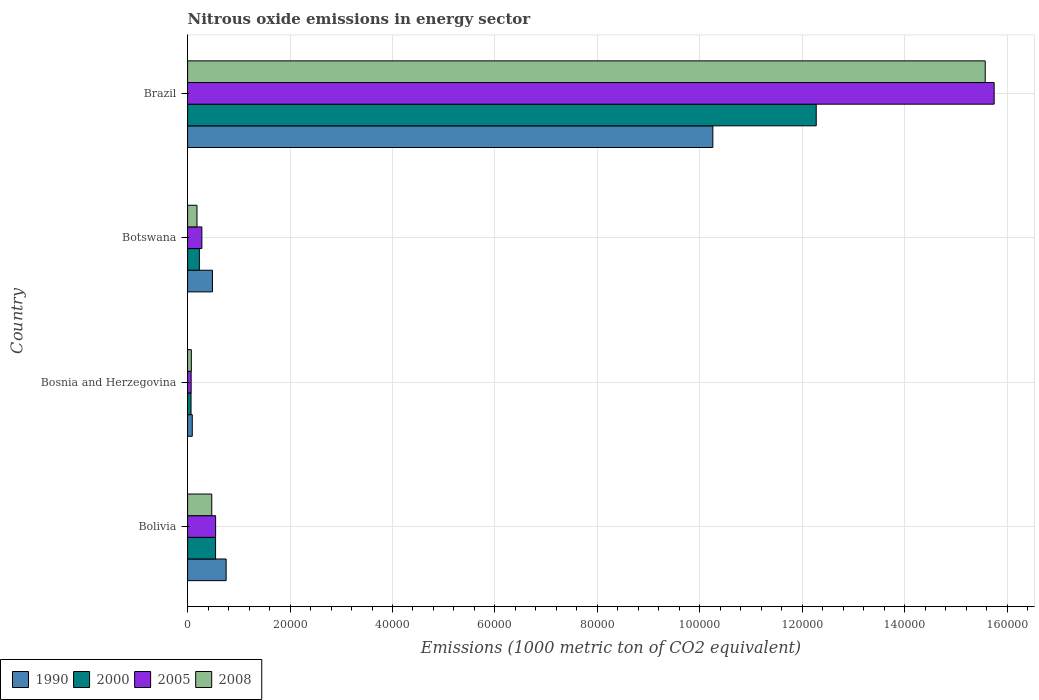How many different coloured bars are there?
Your response must be concise. 4. Are the number of bars on each tick of the Y-axis equal?
Your answer should be very brief. Yes. How many bars are there on the 1st tick from the top?
Your response must be concise. 4. What is the label of the 1st group of bars from the top?
Your answer should be very brief. Brazil. What is the amount of nitrous oxide emitted in 2008 in Bosnia and Herzegovina?
Ensure brevity in your answer.  727.1. Across all countries, what is the maximum amount of nitrous oxide emitted in 1990?
Your answer should be compact. 1.03e+05. Across all countries, what is the minimum amount of nitrous oxide emitted in 2008?
Provide a short and direct response. 727.1. In which country was the amount of nitrous oxide emitted in 2000 minimum?
Your response must be concise. Bosnia and Herzegovina. What is the total amount of nitrous oxide emitted in 1990 in the graph?
Offer a terse response. 1.16e+05. What is the difference between the amount of nitrous oxide emitted in 2008 in Bosnia and Herzegovina and that in Botswana?
Offer a terse response. -1108.7. What is the difference between the amount of nitrous oxide emitted in 2008 in Bolivia and the amount of nitrous oxide emitted in 2005 in Brazil?
Your answer should be compact. -1.53e+05. What is the average amount of nitrous oxide emitted in 1990 per country?
Provide a short and direct response. 2.90e+04. What is the difference between the amount of nitrous oxide emitted in 1990 and amount of nitrous oxide emitted in 2000 in Bosnia and Herzegovina?
Your answer should be compact. 242.9. In how many countries, is the amount of nitrous oxide emitted in 2000 greater than 64000 1000 metric ton?
Make the answer very short. 1. What is the ratio of the amount of nitrous oxide emitted in 2008 in Botswana to that in Brazil?
Ensure brevity in your answer.  0.01. Is the difference between the amount of nitrous oxide emitted in 1990 in Bosnia and Herzegovina and Brazil greater than the difference between the amount of nitrous oxide emitted in 2000 in Bosnia and Herzegovina and Brazil?
Give a very brief answer. Yes. What is the difference between the highest and the second highest amount of nitrous oxide emitted in 2008?
Ensure brevity in your answer.  1.51e+05. What is the difference between the highest and the lowest amount of nitrous oxide emitted in 1990?
Make the answer very short. 1.02e+05. What does the 1st bar from the top in Bosnia and Herzegovina represents?
Your response must be concise. 2008. What does the 2nd bar from the bottom in Botswana represents?
Offer a terse response. 2000. Are all the bars in the graph horizontal?
Offer a terse response. Yes. How many countries are there in the graph?
Keep it short and to the point. 4. What is the difference between two consecutive major ticks on the X-axis?
Offer a very short reply. 2.00e+04. Are the values on the major ticks of X-axis written in scientific E-notation?
Keep it short and to the point. No. What is the title of the graph?
Make the answer very short. Nitrous oxide emissions in energy sector. Does "1966" appear as one of the legend labels in the graph?
Your answer should be compact. No. What is the label or title of the X-axis?
Provide a short and direct response. Emissions (1000 metric ton of CO2 equivalent). What is the label or title of the Y-axis?
Your answer should be very brief. Country. What is the Emissions (1000 metric ton of CO2 equivalent) of 1990 in Bolivia?
Your answer should be compact. 7525.2. What is the Emissions (1000 metric ton of CO2 equivalent) in 2000 in Bolivia?
Make the answer very short. 5463.1. What is the Emissions (1000 metric ton of CO2 equivalent) in 2005 in Bolivia?
Your answer should be very brief. 5470.8. What is the Emissions (1000 metric ton of CO2 equivalent) in 2008 in Bolivia?
Keep it short and to the point. 4717.4. What is the Emissions (1000 metric ton of CO2 equivalent) in 1990 in Bosnia and Herzegovina?
Offer a very short reply. 912.2. What is the Emissions (1000 metric ton of CO2 equivalent) of 2000 in Bosnia and Herzegovina?
Give a very brief answer. 669.3. What is the Emissions (1000 metric ton of CO2 equivalent) of 2005 in Bosnia and Herzegovina?
Give a very brief answer. 691.3. What is the Emissions (1000 metric ton of CO2 equivalent) in 2008 in Bosnia and Herzegovina?
Provide a succinct answer. 727.1. What is the Emissions (1000 metric ton of CO2 equivalent) of 1990 in Botswana?
Keep it short and to the point. 4852.7. What is the Emissions (1000 metric ton of CO2 equivalent) of 2000 in Botswana?
Make the answer very short. 2299. What is the Emissions (1000 metric ton of CO2 equivalent) in 2005 in Botswana?
Provide a short and direct response. 2784.6. What is the Emissions (1000 metric ton of CO2 equivalent) in 2008 in Botswana?
Give a very brief answer. 1835.8. What is the Emissions (1000 metric ton of CO2 equivalent) of 1990 in Brazil?
Offer a terse response. 1.03e+05. What is the Emissions (1000 metric ton of CO2 equivalent) of 2000 in Brazil?
Make the answer very short. 1.23e+05. What is the Emissions (1000 metric ton of CO2 equivalent) of 2005 in Brazil?
Ensure brevity in your answer.  1.57e+05. What is the Emissions (1000 metric ton of CO2 equivalent) in 2008 in Brazil?
Your answer should be compact. 1.56e+05. Across all countries, what is the maximum Emissions (1000 metric ton of CO2 equivalent) of 1990?
Ensure brevity in your answer.  1.03e+05. Across all countries, what is the maximum Emissions (1000 metric ton of CO2 equivalent) in 2000?
Your answer should be compact. 1.23e+05. Across all countries, what is the maximum Emissions (1000 metric ton of CO2 equivalent) of 2005?
Ensure brevity in your answer.  1.57e+05. Across all countries, what is the maximum Emissions (1000 metric ton of CO2 equivalent) of 2008?
Your answer should be compact. 1.56e+05. Across all countries, what is the minimum Emissions (1000 metric ton of CO2 equivalent) of 1990?
Your answer should be very brief. 912.2. Across all countries, what is the minimum Emissions (1000 metric ton of CO2 equivalent) of 2000?
Offer a very short reply. 669.3. Across all countries, what is the minimum Emissions (1000 metric ton of CO2 equivalent) in 2005?
Your answer should be compact. 691.3. Across all countries, what is the minimum Emissions (1000 metric ton of CO2 equivalent) of 2008?
Ensure brevity in your answer.  727.1. What is the total Emissions (1000 metric ton of CO2 equivalent) in 1990 in the graph?
Make the answer very short. 1.16e+05. What is the total Emissions (1000 metric ton of CO2 equivalent) of 2000 in the graph?
Provide a short and direct response. 1.31e+05. What is the total Emissions (1000 metric ton of CO2 equivalent) in 2005 in the graph?
Make the answer very short. 1.66e+05. What is the total Emissions (1000 metric ton of CO2 equivalent) in 2008 in the graph?
Ensure brevity in your answer.  1.63e+05. What is the difference between the Emissions (1000 metric ton of CO2 equivalent) in 1990 in Bolivia and that in Bosnia and Herzegovina?
Your answer should be very brief. 6613. What is the difference between the Emissions (1000 metric ton of CO2 equivalent) in 2000 in Bolivia and that in Bosnia and Herzegovina?
Provide a short and direct response. 4793.8. What is the difference between the Emissions (1000 metric ton of CO2 equivalent) of 2005 in Bolivia and that in Bosnia and Herzegovina?
Your response must be concise. 4779.5. What is the difference between the Emissions (1000 metric ton of CO2 equivalent) of 2008 in Bolivia and that in Bosnia and Herzegovina?
Your answer should be compact. 3990.3. What is the difference between the Emissions (1000 metric ton of CO2 equivalent) of 1990 in Bolivia and that in Botswana?
Offer a very short reply. 2672.5. What is the difference between the Emissions (1000 metric ton of CO2 equivalent) of 2000 in Bolivia and that in Botswana?
Offer a terse response. 3164.1. What is the difference between the Emissions (1000 metric ton of CO2 equivalent) in 2005 in Bolivia and that in Botswana?
Offer a terse response. 2686.2. What is the difference between the Emissions (1000 metric ton of CO2 equivalent) in 2008 in Bolivia and that in Botswana?
Ensure brevity in your answer.  2881.6. What is the difference between the Emissions (1000 metric ton of CO2 equivalent) in 1990 in Bolivia and that in Brazil?
Your response must be concise. -9.50e+04. What is the difference between the Emissions (1000 metric ton of CO2 equivalent) of 2000 in Bolivia and that in Brazil?
Your answer should be very brief. -1.17e+05. What is the difference between the Emissions (1000 metric ton of CO2 equivalent) in 2005 in Bolivia and that in Brazil?
Ensure brevity in your answer.  -1.52e+05. What is the difference between the Emissions (1000 metric ton of CO2 equivalent) in 2008 in Bolivia and that in Brazil?
Make the answer very short. -1.51e+05. What is the difference between the Emissions (1000 metric ton of CO2 equivalent) in 1990 in Bosnia and Herzegovina and that in Botswana?
Offer a terse response. -3940.5. What is the difference between the Emissions (1000 metric ton of CO2 equivalent) of 2000 in Bosnia and Herzegovina and that in Botswana?
Your answer should be compact. -1629.7. What is the difference between the Emissions (1000 metric ton of CO2 equivalent) in 2005 in Bosnia and Herzegovina and that in Botswana?
Your answer should be compact. -2093.3. What is the difference between the Emissions (1000 metric ton of CO2 equivalent) of 2008 in Bosnia and Herzegovina and that in Botswana?
Provide a succinct answer. -1108.7. What is the difference between the Emissions (1000 metric ton of CO2 equivalent) of 1990 in Bosnia and Herzegovina and that in Brazil?
Your answer should be compact. -1.02e+05. What is the difference between the Emissions (1000 metric ton of CO2 equivalent) in 2000 in Bosnia and Herzegovina and that in Brazil?
Make the answer very short. -1.22e+05. What is the difference between the Emissions (1000 metric ton of CO2 equivalent) of 2005 in Bosnia and Herzegovina and that in Brazil?
Your answer should be compact. -1.57e+05. What is the difference between the Emissions (1000 metric ton of CO2 equivalent) of 2008 in Bosnia and Herzegovina and that in Brazil?
Ensure brevity in your answer.  -1.55e+05. What is the difference between the Emissions (1000 metric ton of CO2 equivalent) in 1990 in Botswana and that in Brazil?
Make the answer very short. -9.77e+04. What is the difference between the Emissions (1000 metric ton of CO2 equivalent) of 2000 in Botswana and that in Brazil?
Provide a short and direct response. -1.20e+05. What is the difference between the Emissions (1000 metric ton of CO2 equivalent) in 2005 in Botswana and that in Brazil?
Your answer should be very brief. -1.55e+05. What is the difference between the Emissions (1000 metric ton of CO2 equivalent) of 2008 in Botswana and that in Brazil?
Make the answer very short. -1.54e+05. What is the difference between the Emissions (1000 metric ton of CO2 equivalent) in 1990 in Bolivia and the Emissions (1000 metric ton of CO2 equivalent) in 2000 in Bosnia and Herzegovina?
Give a very brief answer. 6855.9. What is the difference between the Emissions (1000 metric ton of CO2 equivalent) of 1990 in Bolivia and the Emissions (1000 metric ton of CO2 equivalent) of 2005 in Bosnia and Herzegovina?
Make the answer very short. 6833.9. What is the difference between the Emissions (1000 metric ton of CO2 equivalent) of 1990 in Bolivia and the Emissions (1000 metric ton of CO2 equivalent) of 2008 in Bosnia and Herzegovina?
Offer a very short reply. 6798.1. What is the difference between the Emissions (1000 metric ton of CO2 equivalent) of 2000 in Bolivia and the Emissions (1000 metric ton of CO2 equivalent) of 2005 in Bosnia and Herzegovina?
Provide a short and direct response. 4771.8. What is the difference between the Emissions (1000 metric ton of CO2 equivalent) in 2000 in Bolivia and the Emissions (1000 metric ton of CO2 equivalent) in 2008 in Bosnia and Herzegovina?
Ensure brevity in your answer.  4736. What is the difference between the Emissions (1000 metric ton of CO2 equivalent) in 2005 in Bolivia and the Emissions (1000 metric ton of CO2 equivalent) in 2008 in Bosnia and Herzegovina?
Make the answer very short. 4743.7. What is the difference between the Emissions (1000 metric ton of CO2 equivalent) in 1990 in Bolivia and the Emissions (1000 metric ton of CO2 equivalent) in 2000 in Botswana?
Provide a succinct answer. 5226.2. What is the difference between the Emissions (1000 metric ton of CO2 equivalent) in 1990 in Bolivia and the Emissions (1000 metric ton of CO2 equivalent) in 2005 in Botswana?
Provide a succinct answer. 4740.6. What is the difference between the Emissions (1000 metric ton of CO2 equivalent) of 1990 in Bolivia and the Emissions (1000 metric ton of CO2 equivalent) of 2008 in Botswana?
Ensure brevity in your answer.  5689.4. What is the difference between the Emissions (1000 metric ton of CO2 equivalent) of 2000 in Bolivia and the Emissions (1000 metric ton of CO2 equivalent) of 2005 in Botswana?
Your answer should be very brief. 2678.5. What is the difference between the Emissions (1000 metric ton of CO2 equivalent) of 2000 in Bolivia and the Emissions (1000 metric ton of CO2 equivalent) of 2008 in Botswana?
Offer a terse response. 3627.3. What is the difference between the Emissions (1000 metric ton of CO2 equivalent) in 2005 in Bolivia and the Emissions (1000 metric ton of CO2 equivalent) in 2008 in Botswana?
Your response must be concise. 3635. What is the difference between the Emissions (1000 metric ton of CO2 equivalent) of 1990 in Bolivia and the Emissions (1000 metric ton of CO2 equivalent) of 2000 in Brazil?
Give a very brief answer. -1.15e+05. What is the difference between the Emissions (1000 metric ton of CO2 equivalent) in 1990 in Bolivia and the Emissions (1000 metric ton of CO2 equivalent) in 2005 in Brazil?
Keep it short and to the point. -1.50e+05. What is the difference between the Emissions (1000 metric ton of CO2 equivalent) in 1990 in Bolivia and the Emissions (1000 metric ton of CO2 equivalent) in 2008 in Brazil?
Provide a succinct answer. -1.48e+05. What is the difference between the Emissions (1000 metric ton of CO2 equivalent) in 2000 in Bolivia and the Emissions (1000 metric ton of CO2 equivalent) in 2005 in Brazil?
Keep it short and to the point. -1.52e+05. What is the difference between the Emissions (1000 metric ton of CO2 equivalent) of 2000 in Bolivia and the Emissions (1000 metric ton of CO2 equivalent) of 2008 in Brazil?
Offer a terse response. -1.50e+05. What is the difference between the Emissions (1000 metric ton of CO2 equivalent) in 2005 in Bolivia and the Emissions (1000 metric ton of CO2 equivalent) in 2008 in Brazil?
Offer a terse response. -1.50e+05. What is the difference between the Emissions (1000 metric ton of CO2 equivalent) in 1990 in Bosnia and Herzegovina and the Emissions (1000 metric ton of CO2 equivalent) in 2000 in Botswana?
Provide a succinct answer. -1386.8. What is the difference between the Emissions (1000 metric ton of CO2 equivalent) of 1990 in Bosnia and Herzegovina and the Emissions (1000 metric ton of CO2 equivalent) of 2005 in Botswana?
Provide a short and direct response. -1872.4. What is the difference between the Emissions (1000 metric ton of CO2 equivalent) in 1990 in Bosnia and Herzegovina and the Emissions (1000 metric ton of CO2 equivalent) in 2008 in Botswana?
Offer a very short reply. -923.6. What is the difference between the Emissions (1000 metric ton of CO2 equivalent) of 2000 in Bosnia and Herzegovina and the Emissions (1000 metric ton of CO2 equivalent) of 2005 in Botswana?
Offer a very short reply. -2115.3. What is the difference between the Emissions (1000 metric ton of CO2 equivalent) of 2000 in Bosnia and Herzegovina and the Emissions (1000 metric ton of CO2 equivalent) of 2008 in Botswana?
Offer a very short reply. -1166.5. What is the difference between the Emissions (1000 metric ton of CO2 equivalent) in 2005 in Bosnia and Herzegovina and the Emissions (1000 metric ton of CO2 equivalent) in 2008 in Botswana?
Give a very brief answer. -1144.5. What is the difference between the Emissions (1000 metric ton of CO2 equivalent) of 1990 in Bosnia and Herzegovina and the Emissions (1000 metric ton of CO2 equivalent) of 2000 in Brazil?
Give a very brief answer. -1.22e+05. What is the difference between the Emissions (1000 metric ton of CO2 equivalent) in 1990 in Bosnia and Herzegovina and the Emissions (1000 metric ton of CO2 equivalent) in 2005 in Brazil?
Make the answer very short. -1.57e+05. What is the difference between the Emissions (1000 metric ton of CO2 equivalent) in 1990 in Bosnia and Herzegovina and the Emissions (1000 metric ton of CO2 equivalent) in 2008 in Brazil?
Keep it short and to the point. -1.55e+05. What is the difference between the Emissions (1000 metric ton of CO2 equivalent) in 2000 in Bosnia and Herzegovina and the Emissions (1000 metric ton of CO2 equivalent) in 2005 in Brazil?
Offer a terse response. -1.57e+05. What is the difference between the Emissions (1000 metric ton of CO2 equivalent) in 2000 in Bosnia and Herzegovina and the Emissions (1000 metric ton of CO2 equivalent) in 2008 in Brazil?
Your answer should be very brief. -1.55e+05. What is the difference between the Emissions (1000 metric ton of CO2 equivalent) in 2005 in Bosnia and Herzegovina and the Emissions (1000 metric ton of CO2 equivalent) in 2008 in Brazil?
Ensure brevity in your answer.  -1.55e+05. What is the difference between the Emissions (1000 metric ton of CO2 equivalent) in 1990 in Botswana and the Emissions (1000 metric ton of CO2 equivalent) in 2000 in Brazil?
Your answer should be compact. -1.18e+05. What is the difference between the Emissions (1000 metric ton of CO2 equivalent) of 1990 in Botswana and the Emissions (1000 metric ton of CO2 equivalent) of 2005 in Brazil?
Provide a short and direct response. -1.53e+05. What is the difference between the Emissions (1000 metric ton of CO2 equivalent) in 1990 in Botswana and the Emissions (1000 metric ton of CO2 equivalent) in 2008 in Brazil?
Offer a terse response. -1.51e+05. What is the difference between the Emissions (1000 metric ton of CO2 equivalent) in 2000 in Botswana and the Emissions (1000 metric ton of CO2 equivalent) in 2005 in Brazil?
Your response must be concise. -1.55e+05. What is the difference between the Emissions (1000 metric ton of CO2 equivalent) in 2000 in Botswana and the Emissions (1000 metric ton of CO2 equivalent) in 2008 in Brazil?
Keep it short and to the point. -1.53e+05. What is the difference between the Emissions (1000 metric ton of CO2 equivalent) of 2005 in Botswana and the Emissions (1000 metric ton of CO2 equivalent) of 2008 in Brazil?
Keep it short and to the point. -1.53e+05. What is the average Emissions (1000 metric ton of CO2 equivalent) in 1990 per country?
Ensure brevity in your answer.  2.90e+04. What is the average Emissions (1000 metric ton of CO2 equivalent) of 2000 per country?
Your response must be concise. 3.28e+04. What is the average Emissions (1000 metric ton of CO2 equivalent) in 2005 per country?
Ensure brevity in your answer.  4.16e+04. What is the average Emissions (1000 metric ton of CO2 equivalent) of 2008 per country?
Your answer should be very brief. 4.07e+04. What is the difference between the Emissions (1000 metric ton of CO2 equivalent) of 1990 and Emissions (1000 metric ton of CO2 equivalent) of 2000 in Bolivia?
Offer a very short reply. 2062.1. What is the difference between the Emissions (1000 metric ton of CO2 equivalent) of 1990 and Emissions (1000 metric ton of CO2 equivalent) of 2005 in Bolivia?
Provide a succinct answer. 2054.4. What is the difference between the Emissions (1000 metric ton of CO2 equivalent) of 1990 and Emissions (1000 metric ton of CO2 equivalent) of 2008 in Bolivia?
Keep it short and to the point. 2807.8. What is the difference between the Emissions (1000 metric ton of CO2 equivalent) in 2000 and Emissions (1000 metric ton of CO2 equivalent) in 2005 in Bolivia?
Give a very brief answer. -7.7. What is the difference between the Emissions (1000 metric ton of CO2 equivalent) of 2000 and Emissions (1000 metric ton of CO2 equivalent) of 2008 in Bolivia?
Your answer should be compact. 745.7. What is the difference between the Emissions (1000 metric ton of CO2 equivalent) in 2005 and Emissions (1000 metric ton of CO2 equivalent) in 2008 in Bolivia?
Your answer should be very brief. 753.4. What is the difference between the Emissions (1000 metric ton of CO2 equivalent) of 1990 and Emissions (1000 metric ton of CO2 equivalent) of 2000 in Bosnia and Herzegovina?
Offer a very short reply. 242.9. What is the difference between the Emissions (1000 metric ton of CO2 equivalent) in 1990 and Emissions (1000 metric ton of CO2 equivalent) in 2005 in Bosnia and Herzegovina?
Offer a terse response. 220.9. What is the difference between the Emissions (1000 metric ton of CO2 equivalent) in 1990 and Emissions (1000 metric ton of CO2 equivalent) in 2008 in Bosnia and Herzegovina?
Keep it short and to the point. 185.1. What is the difference between the Emissions (1000 metric ton of CO2 equivalent) in 2000 and Emissions (1000 metric ton of CO2 equivalent) in 2005 in Bosnia and Herzegovina?
Provide a short and direct response. -22. What is the difference between the Emissions (1000 metric ton of CO2 equivalent) of 2000 and Emissions (1000 metric ton of CO2 equivalent) of 2008 in Bosnia and Herzegovina?
Provide a succinct answer. -57.8. What is the difference between the Emissions (1000 metric ton of CO2 equivalent) of 2005 and Emissions (1000 metric ton of CO2 equivalent) of 2008 in Bosnia and Herzegovina?
Make the answer very short. -35.8. What is the difference between the Emissions (1000 metric ton of CO2 equivalent) of 1990 and Emissions (1000 metric ton of CO2 equivalent) of 2000 in Botswana?
Your answer should be compact. 2553.7. What is the difference between the Emissions (1000 metric ton of CO2 equivalent) of 1990 and Emissions (1000 metric ton of CO2 equivalent) of 2005 in Botswana?
Make the answer very short. 2068.1. What is the difference between the Emissions (1000 metric ton of CO2 equivalent) of 1990 and Emissions (1000 metric ton of CO2 equivalent) of 2008 in Botswana?
Your answer should be compact. 3016.9. What is the difference between the Emissions (1000 metric ton of CO2 equivalent) of 2000 and Emissions (1000 metric ton of CO2 equivalent) of 2005 in Botswana?
Offer a very short reply. -485.6. What is the difference between the Emissions (1000 metric ton of CO2 equivalent) in 2000 and Emissions (1000 metric ton of CO2 equivalent) in 2008 in Botswana?
Ensure brevity in your answer.  463.2. What is the difference between the Emissions (1000 metric ton of CO2 equivalent) in 2005 and Emissions (1000 metric ton of CO2 equivalent) in 2008 in Botswana?
Offer a terse response. 948.8. What is the difference between the Emissions (1000 metric ton of CO2 equivalent) of 1990 and Emissions (1000 metric ton of CO2 equivalent) of 2000 in Brazil?
Keep it short and to the point. -2.02e+04. What is the difference between the Emissions (1000 metric ton of CO2 equivalent) in 1990 and Emissions (1000 metric ton of CO2 equivalent) in 2005 in Brazil?
Your answer should be compact. -5.49e+04. What is the difference between the Emissions (1000 metric ton of CO2 equivalent) of 1990 and Emissions (1000 metric ton of CO2 equivalent) of 2008 in Brazil?
Your response must be concise. -5.32e+04. What is the difference between the Emissions (1000 metric ton of CO2 equivalent) in 2000 and Emissions (1000 metric ton of CO2 equivalent) in 2005 in Brazil?
Provide a short and direct response. -3.47e+04. What is the difference between the Emissions (1000 metric ton of CO2 equivalent) of 2000 and Emissions (1000 metric ton of CO2 equivalent) of 2008 in Brazil?
Ensure brevity in your answer.  -3.30e+04. What is the difference between the Emissions (1000 metric ton of CO2 equivalent) of 2005 and Emissions (1000 metric ton of CO2 equivalent) of 2008 in Brazil?
Provide a short and direct response. 1744.8. What is the ratio of the Emissions (1000 metric ton of CO2 equivalent) in 1990 in Bolivia to that in Bosnia and Herzegovina?
Offer a very short reply. 8.25. What is the ratio of the Emissions (1000 metric ton of CO2 equivalent) of 2000 in Bolivia to that in Bosnia and Herzegovina?
Offer a terse response. 8.16. What is the ratio of the Emissions (1000 metric ton of CO2 equivalent) in 2005 in Bolivia to that in Bosnia and Herzegovina?
Your answer should be compact. 7.91. What is the ratio of the Emissions (1000 metric ton of CO2 equivalent) in 2008 in Bolivia to that in Bosnia and Herzegovina?
Ensure brevity in your answer.  6.49. What is the ratio of the Emissions (1000 metric ton of CO2 equivalent) of 1990 in Bolivia to that in Botswana?
Offer a terse response. 1.55. What is the ratio of the Emissions (1000 metric ton of CO2 equivalent) of 2000 in Bolivia to that in Botswana?
Your answer should be compact. 2.38. What is the ratio of the Emissions (1000 metric ton of CO2 equivalent) in 2005 in Bolivia to that in Botswana?
Make the answer very short. 1.96. What is the ratio of the Emissions (1000 metric ton of CO2 equivalent) in 2008 in Bolivia to that in Botswana?
Your answer should be very brief. 2.57. What is the ratio of the Emissions (1000 metric ton of CO2 equivalent) of 1990 in Bolivia to that in Brazil?
Offer a very short reply. 0.07. What is the ratio of the Emissions (1000 metric ton of CO2 equivalent) of 2000 in Bolivia to that in Brazil?
Make the answer very short. 0.04. What is the ratio of the Emissions (1000 metric ton of CO2 equivalent) of 2005 in Bolivia to that in Brazil?
Ensure brevity in your answer.  0.03. What is the ratio of the Emissions (1000 metric ton of CO2 equivalent) in 2008 in Bolivia to that in Brazil?
Your answer should be very brief. 0.03. What is the ratio of the Emissions (1000 metric ton of CO2 equivalent) in 1990 in Bosnia and Herzegovina to that in Botswana?
Offer a very short reply. 0.19. What is the ratio of the Emissions (1000 metric ton of CO2 equivalent) in 2000 in Bosnia and Herzegovina to that in Botswana?
Offer a terse response. 0.29. What is the ratio of the Emissions (1000 metric ton of CO2 equivalent) of 2005 in Bosnia and Herzegovina to that in Botswana?
Provide a short and direct response. 0.25. What is the ratio of the Emissions (1000 metric ton of CO2 equivalent) in 2008 in Bosnia and Herzegovina to that in Botswana?
Provide a short and direct response. 0.4. What is the ratio of the Emissions (1000 metric ton of CO2 equivalent) of 1990 in Bosnia and Herzegovina to that in Brazil?
Offer a terse response. 0.01. What is the ratio of the Emissions (1000 metric ton of CO2 equivalent) of 2000 in Bosnia and Herzegovina to that in Brazil?
Give a very brief answer. 0.01. What is the ratio of the Emissions (1000 metric ton of CO2 equivalent) in 2005 in Bosnia and Herzegovina to that in Brazil?
Make the answer very short. 0. What is the ratio of the Emissions (1000 metric ton of CO2 equivalent) in 2008 in Bosnia and Herzegovina to that in Brazil?
Offer a very short reply. 0. What is the ratio of the Emissions (1000 metric ton of CO2 equivalent) of 1990 in Botswana to that in Brazil?
Your answer should be compact. 0.05. What is the ratio of the Emissions (1000 metric ton of CO2 equivalent) of 2000 in Botswana to that in Brazil?
Your answer should be very brief. 0.02. What is the ratio of the Emissions (1000 metric ton of CO2 equivalent) in 2005 in Botswana to that in Brazil?
Your response must be concise. 0.02. What is the ratio of the Emissions (1000 metric ton of CO2 equivalent) in 2008 in Botswana to that in Brazil?
Your answer should be compact. 0.01. What is the difference between the highest and the second highest Emissions (1000 metric ton of CO2 equivalent) in 1990?
Make the answer very short. 9.50e+04. What is the difference between the highest and the second highest Emissions (1000 metric ton of CO2 equivalent) of 2000?
Offer a terse response. 1.17e+05. What is the difference between the highest and the second highest Emissions (1000 metric ton of CO2 equivalent) in 2005?
Ensure brevity in your answer.  1.52e+05. What is the difference between the highest and the second highest Emissions (1000 metric ton of CO2 equivalent) of 2008?
Provide a short and direct response. 1.51e+05. What is the difference between the highest and the lowest Emissions (1000 metric ton of CO2 equivalent) of 1990?
Offer a terse response. 1.02e+05. What is the difference between the highest and the lowest Emissions (1000 metric ton of CO2 equivalent) of 2000?
Give a very brief answer. 1.22e+05. What is the difference between the highest and the lowest Emissions (1000 metric ton of CO2 equivalent) in 2005?
Offer a very short reply. 1.57e+05. What is the difference between the highest and the lowest Emissions (1000 metric ton of CO2 equivalent) in 2008?
Provide a succinct answer. 1.55e+05. 